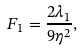<formula> <loc_0><loc_0><loc_500><loc_500>F _ { 1 } = \frac { 2 \lambda _ { 1 } } { 9 \eta ^ { 2 } } ,</formula> 